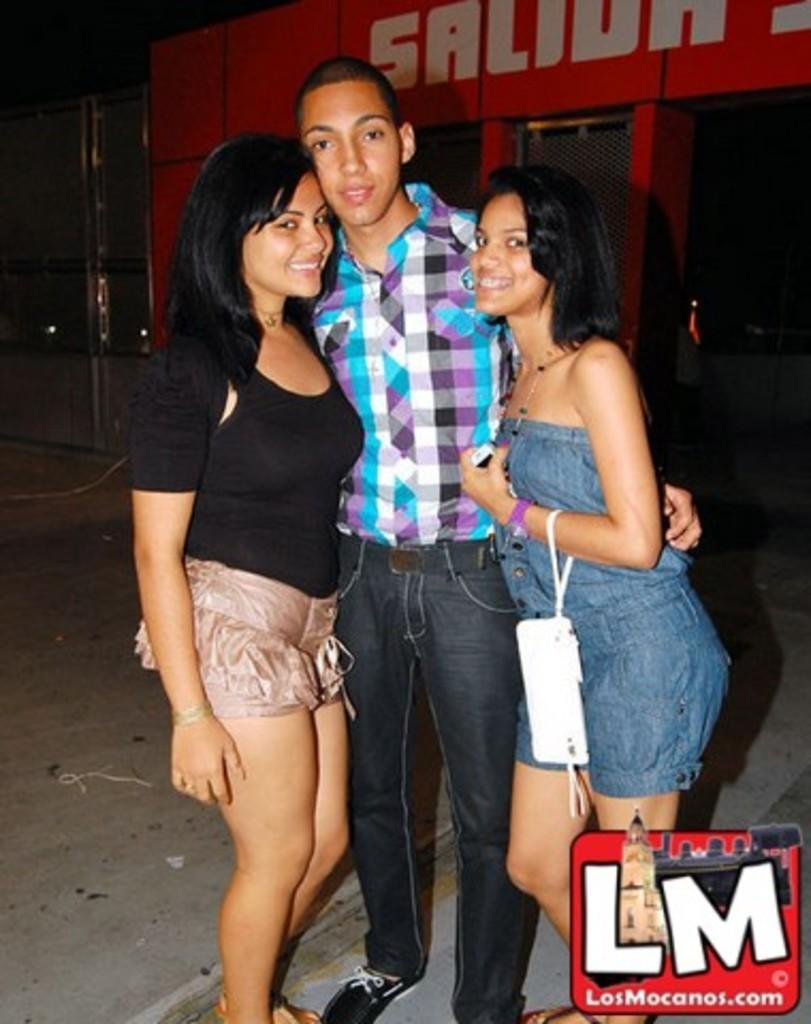Could you give a brief overview of what you see in this image? In this image we can see few people. There is some text at the right side of the image. There is some text and a logo at the bottom left most of the image. There is a handbag in the image. 